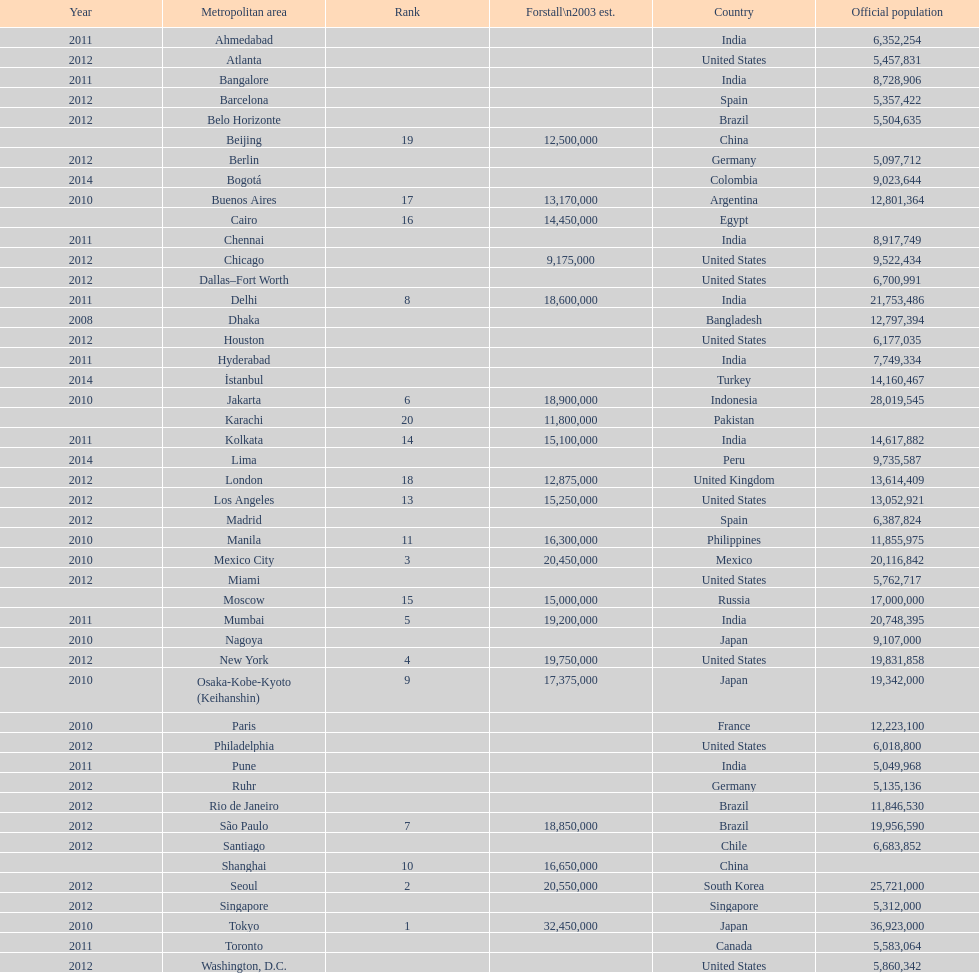What city was ranked first in 2003? Tokyo. 